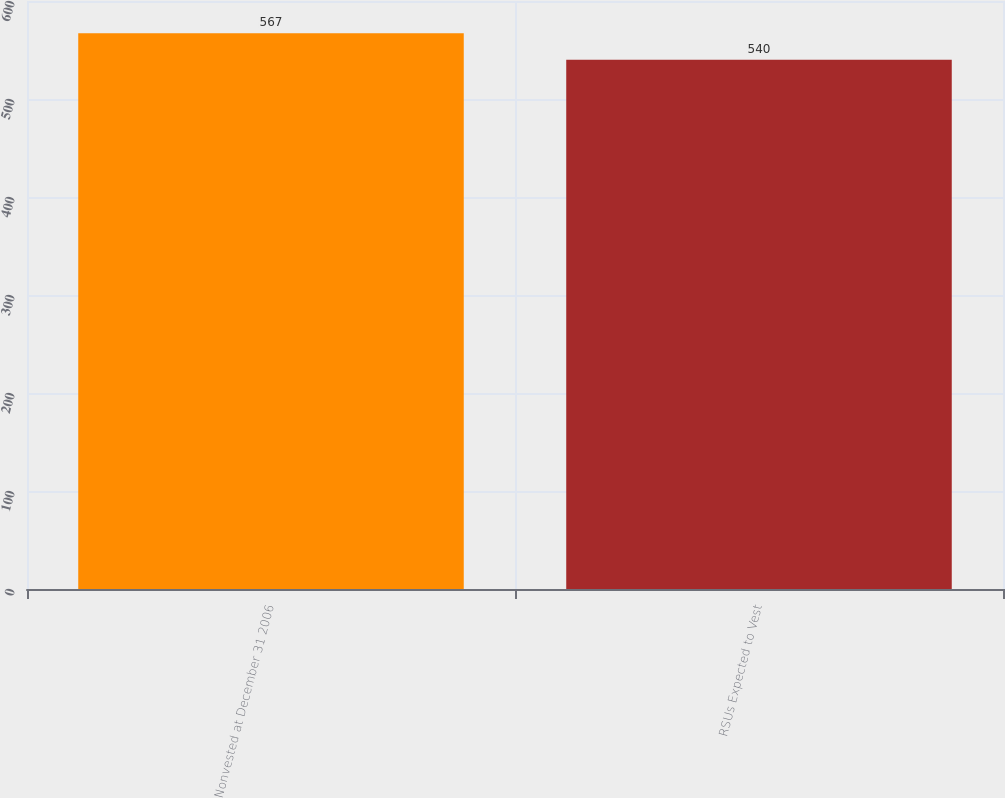Convert chart. <chart><loc_0><loc_0><loc_500><loc_500><bar_chart><fcel>Nonvested at December 31 2006<fcel>RSUs Expected to Vest<nl><fcel>567<fcel>540<nl></chart> 